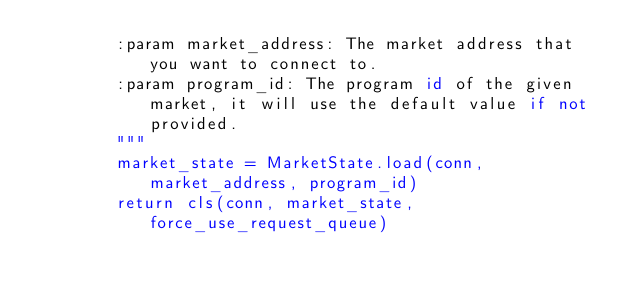<code> <loc_0><loc_0><loc_500><loc_500><_Python_>        :param market_address: The market address that you want to connect to.
        :param program_id: The program id of the given market, it will use the default value if not provided.
        """
        market_state = MarketState.load(conn, market_address, program_id)
        return cls(conn, market_state, force_use_request_queue)
</code> 